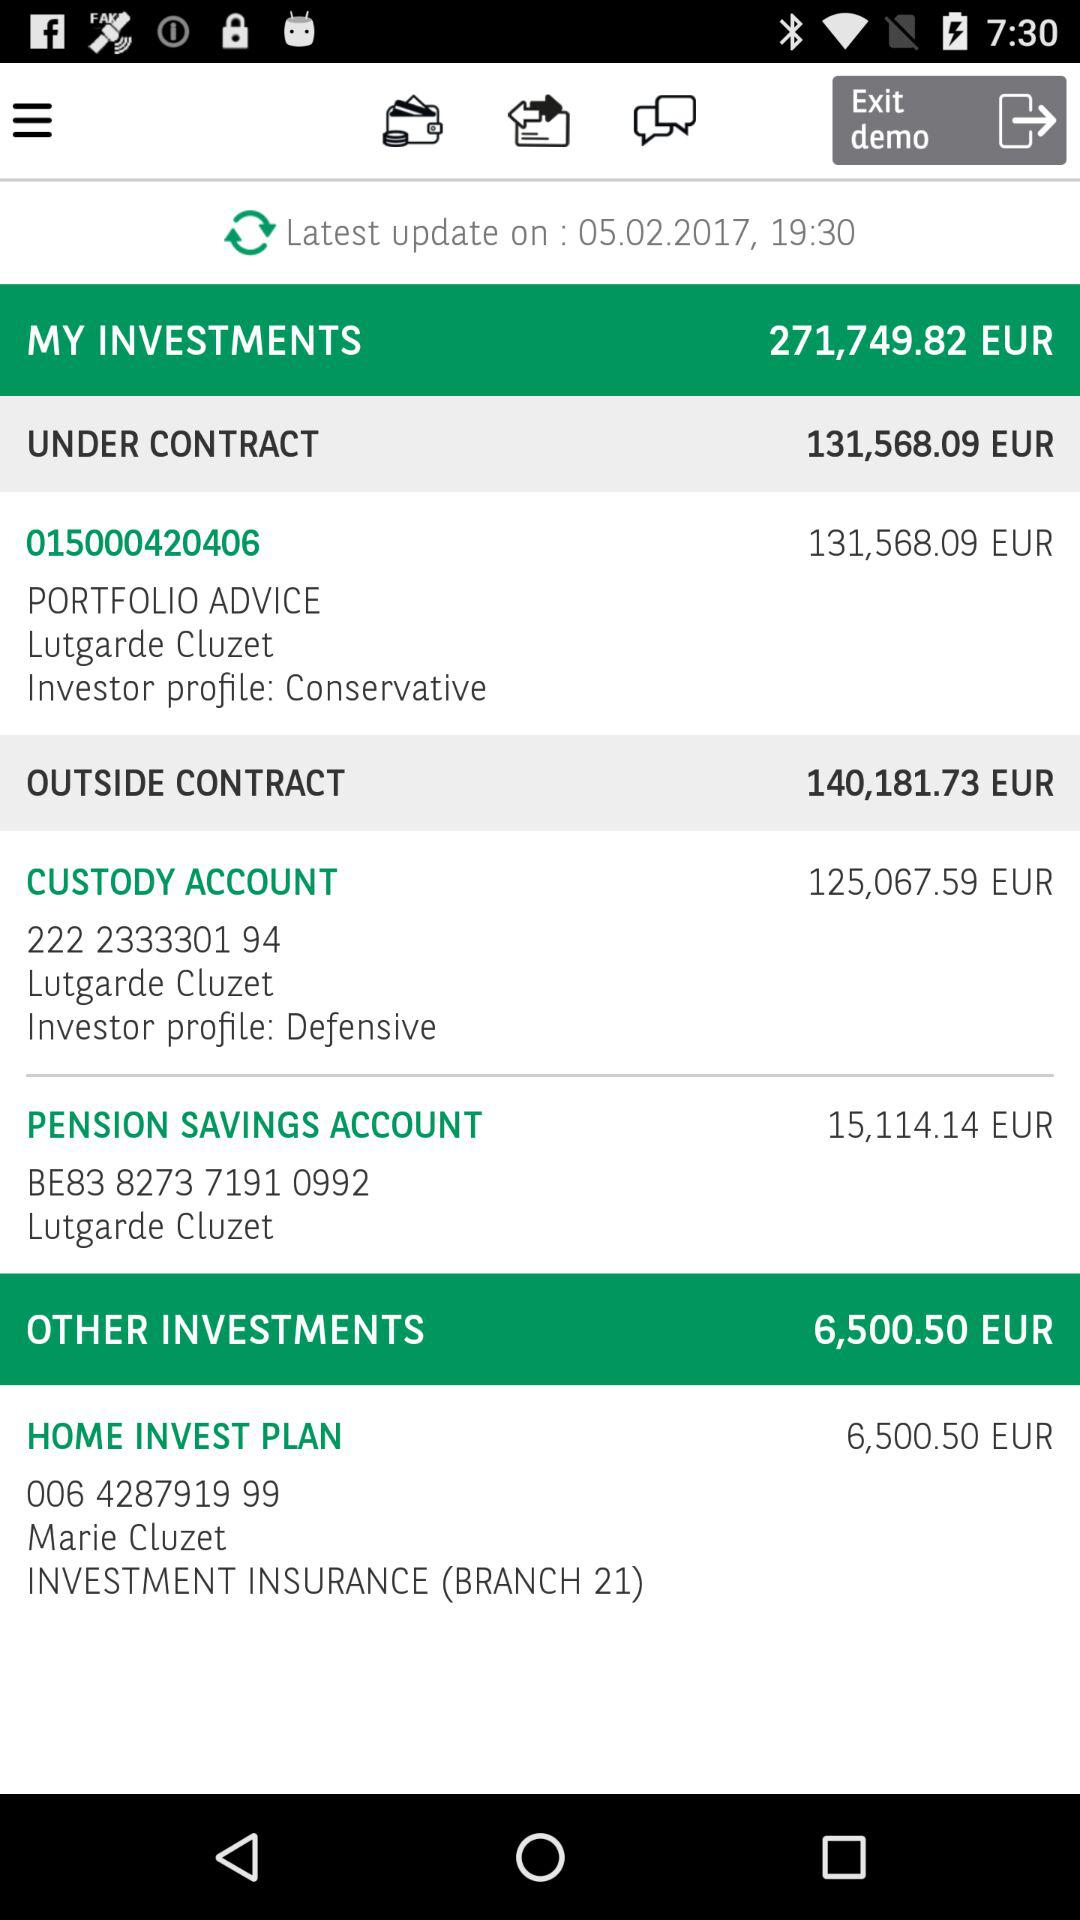How much EUR is under contract? There is 131,568.09 EUR under contract. 